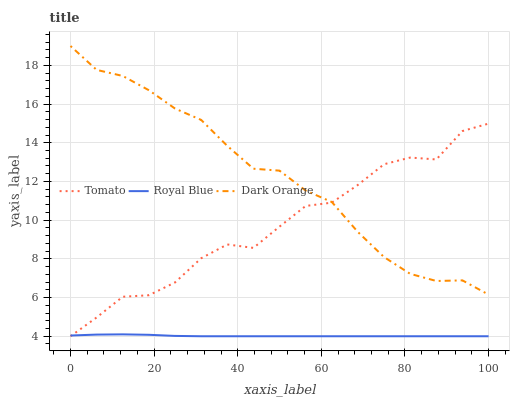Does Royal Blue have the minimum area under the curve?
Answer yes or no. Yes. Does Dark Orange have the maximum area under the curve?
Answer yes or no. Yes. Does Dark Orange have the minimum area under the curve?
Answer yes or no. No. Does Royal Blue have the maximum area under the curve?
Answer yes or no. No. Is Royal Blue the smoothest?
Answer yes or no. Yes. Is Tomato the roughest?
Answer yes or no. Yes. Is Dark Orange the smoothest?
Answer yes or no. No. Is Dark Orange the roughest?
Answer yes or no. No. Does Tomato have the lowest value?
Answer yes or no. Yes. Does Dark Orange have the lowest value?
Answer yes or no. No. Does Dark Orange have the highest value?
Answer yes or no. Yes. Does Royal Blue have the highest value?
Answer yes or no. No. Is Royal Blue less than Dark Orange?
Answer yes or no. Yes. Is Dark Orange greater than Royal Blue?
Answer yes or no. Yes. Does Royal Blue intersect Tomato?
Answer yes or no. Yes. Is Royal Blue less than Tomato?
Answer yes or no. No. Is Royal Blue greater than Tomato?
Answer yes or no. No. Does Royal Blue intersect Dark Orange?
Answer yes or no. No. 